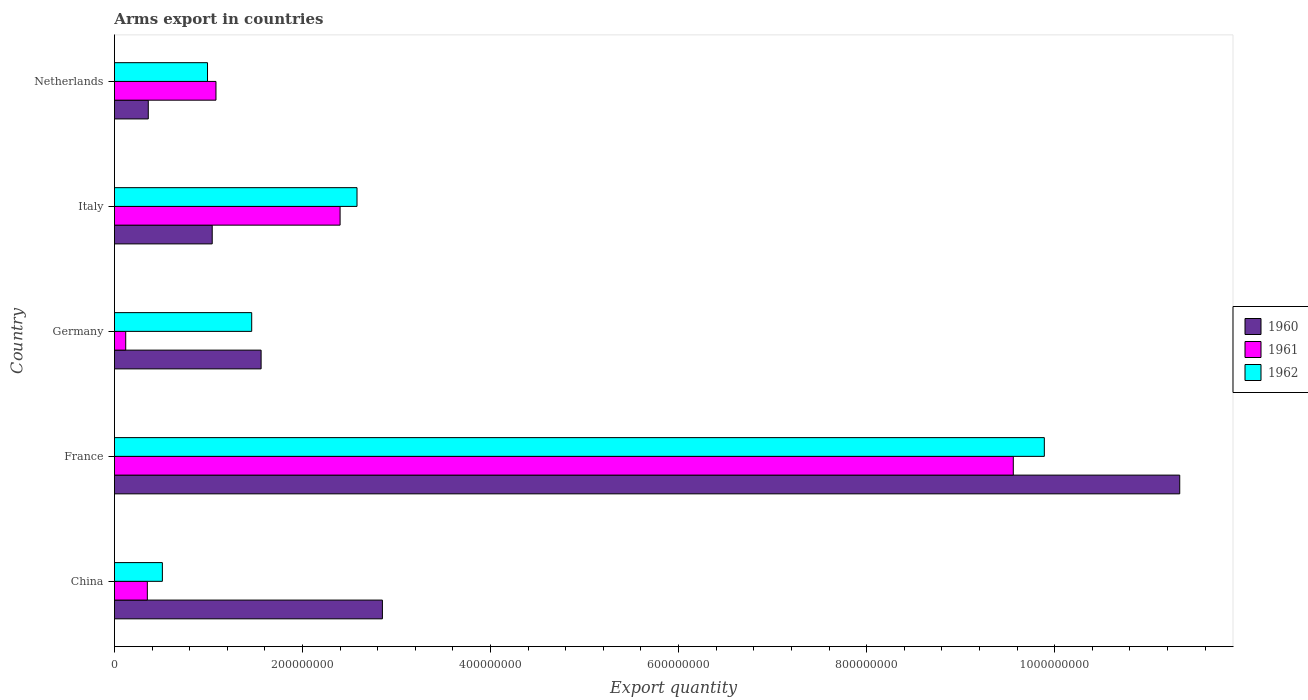How many groups of bars are there?
Give a very brief answer. 5. How many bars are there on the 1st tick from the top?
Provide a succinct answer. 3. What is the label of the 5th group of bars from the top?
Keep it short and to the point. China. What is the total arms export in 1961 in France?
Your answer should be very brief. 9.56e+08. Across all countries, what is the maximum total arms export in 1962?
Your response must be concise. 9.89e+08. In which country was the total arms export in 1961 maximum?
Give a very brief answer. France. What is the total total arms export in 1962 in the graph?
Provide a short and direct response. 1.54e+09. What is the difference between the total arms export in 1962 in China and that in Netherlands?
Your answer should be compact. -4.80e+07. What is the difference between the total arms export in 1962 in China and the total arms export in 1961 in France?
Your response must be concise. -9.05e+08. What is the average total arms export in 1960 per country?
Keep it short and to the point. 3.43e+08. What is the difference between the total arms export in 1960 and total arms export in 1962 in Germany?
Make the answer very short. 1.00e+07. What is the ratio of the total arms export in 1960 in China to that in Italy?
Provide a short and direct response. 2.74. Is the difference between the total arms export in 1960 in China and France greater than the difference between the total arms export in 1962 in China and France?
Offer a terse response. Yes. What is the difference between the highest and the second highest total arms export in 1961?
Give a very brief answer. 7.16e+08. What is the difference between the highest and the lowest total arms export in 1961?
Your answer should be compact. 9.44e+08. In how many countries, is the total arms export in 1961 greater than the average total arms export in 1961 taken over all countries?
Ensure brevity in your answer.  1. Is the sum of the total arms export in 1961 in China and Italy greater than the maximum total arms export in 1960 across all countries?
Your response must be concise. No. What does the 2nd bar from the top in Germany represents?
Offer a terse response. 1961. Are all the bars in the graph horizontal?
Provide a short and direct response. Yes. Does the graph contain any zero values?
Make the answer very short. No. Does the graph contain grids?
Your answer should be very brief. No. Where does the legend appear in the graph?
Keep it short and to the point. Center right. How many legend labels are there?
Your answer should be very brief. 3. What is the title of the graph?
Provide a short and direct response. Arms export in countries. Does "2007" appear as one of the legend labels in the graph?
Provide a short and direct response. No. What is the label or title of the X-axis?
Your response must be concise. Export quantity. What is the Export quantity of 1960 in China?
Ensure brevity in your answer.  2.85e+08. What is the Export quantity of 1961 in China?
Keep it short and to the point. 3.50e+07. What is the Export quantity in 1962 in China?
Ensure brevity in your answer.  5.10e+07. What is the Export quantity in 1960 in France?
Give a very brief answer. 1.13e+09. What is the Export quantity of 1961 in France?
Your answer should be very brief. 9.56e+08. What is the Export quantity in 1962 in France?
Offer a very short reply. 9.89e+08. What is the Export quantity of 1960 in Germany?
Provide a short and direct response. 1.56e+08. What is the Export quantity of 1962 in Germany?
Your response must be concise. 1.46e+08. What is the Export quantity in 1960 in Italy?
Provide a succinct answer. 1.04e+08. What is the Export quantity of 1961 in Italy?
Offer a terse response. 2.40e+08. What is the Export quantity in 1962 in Italy?
Provide a succinct answer. 2.58e+08. What is the Export quantity in 1960 in Netherlands?
Offer a terse response. 3.60e+07. What is the Export quantity in 1961 in Netherlands?
Your answer should be compact. 1.08e+08. What is the Export quantity in 1962 in Netherlands?
Your answer should be very brief. 9.90e+07. Across all countries, what is the maximum Export quantity in 1960?
Offer a very short reply. 1.13e+09. Across all countries, what is the maximum Export quantity in 1961?
Ensure brevity in your answer.  9.56e+08. Across all countries, what is the maximum Export quantity in 1962?
Give a very brief answer. 9.89e+08. Across all countries, what is the minimum Export quantity in 1960?
Ensure brevity in your answer.  3.60e+07. Across all countries, what is the minimum Export quantity in 1962?
Your answer should be compact. 5.10e+07. What is the total Export quantity of 1960 in the graph?
Provide a succinct answer. 1.71e+09. What is the total Export quantity of 1961 in the graph?
Offer a terse response. 1.35e+09. What is the total Export quantity in 1962 in the graph?
Give a very brief answer. 1.54e+09. What is the difference between the Export quantity of 1960 in China and that in France?
Your response must be concise. -8.48e+08. What is the difference between the Export quantity of 1961 in China and that in France?
Give a very brief answer. -9.21e+08. What is the difference between the Export quantity in 1962 in China and that in France?
Keep it short and to the point. -9.38e+08. What is the difference between the Export quantity in 1960 in China and that in Germany?
Keep it short and to the point. 1.29e+08. What is the difference between the Export quantity in 1961 in China and that in Germany?
Keep it short and to the point. 2.30e+07. What is the difference between the Export quantity in 1962 in China and that in Germany?
Provide a succinct answer. -9.50e+07. What is the difference between the Export quantity of 1960 in China and that in Italy?
Make the answer very short. 1.81e+08. What is the difference between the Export quantity in 1961 in China and that in Italy?
Give a very brief answer. -2.05e+08. What is the difference between the Export quantity of 1962 in China and that in Italy?
Provide a succinct answer. -2.07e+08. What is the difference between the Export quantity in 1960 in China and that in Netherlands?
Keep it short and to the point. 2.49e+08. What is the difference between the Export quantity in 1961 in China and that in Netherlands?
Your answer should be compact. -7.30e+07. What is the difference between the Export quantity in 1962 in China and that in Netherlands?
Ensure brevity in your answer.  -4.80e+07. What is the difference between the Export quantity of 1960 in France and that in Germany?
Give a very brief answer. 9.77e+08. What is the difference between the Export quantity in 1961 in France and that in Germany?
Provide a short and direct response. 9.44e+08. What is the difference between the Export quantity of 1962 in France and that in Germany?
Offer a terse response. 8.43e+08. What is the difference between the Export quantity of 1960 in France and that in Italy?
Provide a short and direct response. 1.03e+09. What is the difference between the Export quantity in 1961 in France and that in Italy?
Make the answer very short. 7.16e+08. What is the difference between the Export quantity in 1962 in France and that in Italy?
Provide a succinct answer. 7.31e+08. What is the difference between the Export quantity of 1960 in France and that in Netherlands?
Provide a short and direct response. 1.10e+09. What is the difference between the Export quantity in 1961 in France and that in Netherlands?
Your answer should be compact. 8.48e+08. What is the difference between the Export quantity in 1962 in France and that in Netherlands?
Your answer should be compact. 8.90e+08. What is the difference between the Export quantity of 1960 in Germany and that in Italy?
Your answer should be very brief. 5.20e+07. What is the difference between the Export quantity of 1961 in Germany and that in Italy?
Give a very brief answer. -2.28e+08. What is the difference between the Export quantity in 1962 in Germany and that in Italy?
Provide a succinct answer. -1.12e+08. What is the difference between the Export quantity of 1960 in Germany and that in Netherlands?
Offer a terse response. 1.20e+08. What is the difference between the Export quantity of 1961 in Germany and that in Netherlands?
Give a very brief answer. -9.60e+07. What is the difference between the Export quantity of 1962 in Germany and that in Netherlands?
Your answer should be compact. 4.70e+07. What is the difference between the Export quantity of 1960 in Italy and that in Netherlands?
Your response must be concise. 6.80e+07. What is the difference between the Export quantity of 1961 in Italy and that in Netherlands?
Keep it short and to the point. 1.32e+08. What is the difference between the Export quantity in 1962 in Italy and that in Netherlands?
Your response must be concise. 1.59e+08. What is the difference between the Export quantity in 1960 in China and the Export quantity in 1961 in France?
Your answer should be compact. -6.71e+08. What is the difference between the Export quantity in 1960 in China and the Export quantity in 1962 in France?
Provide a short and direct response. -7.04e+08. What is the difference between the Export quantity of 1961 in China and the Export quantity of 1962 in France?
Give a very brief answer. -9.54e+08. What is the difference between the Export quantity in 1960 in China and the Export quantity in 1961 in Germany?
Your response must be concise. 2.73e+08. What is the difference between the Export quantity of 1960 in China and the Export quantity of 1962 in Germany?
Ensure brevity in your answer.  1.39e+08. What is the difference between the Export quantity of 1961 in China and the Export quantity of 1962 in Germany?
Make the answer very short. -1.11e+08. What is the difference between the Export quantity of 1960 in China and the Export quantity of 1961 in Italy?
Provide a succinct answer. 4.50e+07. What is the difference between the Export quantity in 1960 in China and the Export quantity in 1962 in Italy?
Give a very brief answer. 2.70e+07. What is the difference between the Export quantity in 1961 in China and the Export quantity in 1962 in Italy?
Give a very brief answer. -2.23e+08. What is the difference between the Export quantity in 1960 in China and the Export quantity in 1961 in Netherlands?
Your response must be concise. 1.77e+08. What is the difference between the Export quantity of 1960 in China and the Export quantity of 1962 in Netherlands?
Ensure brevity in your answer.  1.86e+08. What is the difference between the Export quantity in 1961 in China and the Export quantity in 1962 in Netherlands?
Offer a very short reply. -6.40e+07. What is the difference between the Export quantity of 1960 in France and the Export quantity of 1961 in Germany?
Keep it short and to the point. 1.12e+09. What is the difference between the Export quantity in 1960 in France and the Export quantity in 1962 in Germany?
Make the answer very short. 9.87e+08. What is the difference between the Export quantity of 1961 in France and the Export quantity of 1962 in Germany?
Make the answer very short. 8.10e+08. What is the difference between the Export quantity of 1960 in France and the Export quantity of 1961 in Italy?
Your answer should be compact. 8.93e+08. What is the difference between the Export quantity of 1960 in France and the Export quantity of 1962 in Italy?
Keep it short and to the point. 8.75e+08. What is the difference between the Export quantity of 1961 in France and the Export quantity of 1962 in Italy?
Offer a very short reply. 6.98e+08. What is the difference between the Export quantity in 1960 in France and the Export quantity in 1961 in Netherlands?
Keep it short and to the point. 1.02e+09. What is the difference between the Export quantity in 1960 in France and the Export quantity in 1962 in Netherlands?
Ensure brevity in your answer.  1.03e+09. What is the difference between the Export quantity of 1961 in France and the Export quantity of 1962 in Netherlands?
Ensure brevity in your answer.  8.57e+08. What is the difference between the Export quantity of 1960 in Germany and the Export quantity of 1961 in Italy?
Offer a very short reply. -8.40e+07. What is the difference between the Export quantity of 1960 in Germany and the Export quantity of 1962 in Italy?
Offer a terse response. -1.02e+08. What is the difference between the Export quantity of 1961 in Germany and the Export quantity of 1962 in Italy?
Provide a short and direct response. -2.46e+08. What is the difference between the Export quantity in 1960 in Germany and the Export quantity in 1961 in Netherlands?
Provide a succinct answer. 4.80e+07. What is the difference between the Export quantity in 1960 in Germany and the Export quantity in 1962 in Netherlands?
Offer a very short reply. 5.70e+07. What is the difference between the Export quantity of 1961 in Germany and the Export quantity of 1962 in Netherlands?
Your answer should be very brief. -8.70e+07. What is the difference between the Export quantity in 1960 in Italy and the Export quantity in 1961 in Netherlands?
Ensure brevity in your answer.  -4.00e+06. What is the difference between the Export quantity in 1961 in Italy and the Export quantity in 1962 in Netherlands?
Offer a terse response. 1.41e+08. What is the average Export quantity in 1960 per country?
Your answer should be compact. 3.43e+08. What is the average Export quantity in 1961 per country?
Ensure brevity in your answer.  2.70e+08. What is the average Export quantity of 1962 per country?
Your response must be concise. 3.09e+08. What is the difference between the Export quantity of 1960 and Export quantity of 1961 in China?
Your answer should be compact. 2.50e+08. What is the difference between the Export quantity of 1960 and Export quantity of 1962 in China?
Make the answer very short. 2.34e+08. What is the difference between the Export quantity of 1961 and Export quantity of 1962 in China?
Your response must be concise. -1.60e+07. What is the difference between the Export quantity in 1960 and Export quantity in 1961 in France?
Your answer should be very brief. 1.77e+08. What is the difference between the Export quantity in 1960 and Export quantity in 1962 in France?
Offer a very short reply. 1.44e+08. What is the difference between the Export quantity of 1961 and Export quantity of 1962 in France?
Your answer should be very brief. -3.30e+07. What is the difference between the Export quantity of 1960 and Export quantity of 1961 in Germany?
Offer a very short reply. 1.44e+08. What is the difference between the Export quantity in 1960 and Export quantity in 1962 in Germany?
Ensure brevity in your answer.  1.00e+07. What is the difference between the Export quantity of 1961 and Export quantity of 1962 in Germany?
Give a very brief answer. -1.34e+08. What is the difference between the Export quantity of 1960 and Export quantity of 1961 in Italy?
Offer a very short reply. -1.36e+08. What is the difference between the Export quantity in 1960 and Export quantity in 1962 in Italy?
Make the answer very short. -1.54e+08. What is the difference between the Export quantity in 1961 and Export quantity in 1962 in Italy?
Provide a succinct answer. -1.80e+07. What is the difference between the Export quantity of 1960 and Export quantity of 1961 in Netherlands?
Make the answer very short. -7.20e+07. What is the difference between the Export quantity in 1960 and Export quantity in 1962 in Netherlands?
Your response must be concise. -6.30e+07. What is the difference between the Export quantity of 1961 and Export quantity of 1962 in Netherlands?
Offer a very short reply. 9.00e+06. What is the ratio of the Export quantity in 1960 in China to that in France?
Keep it short and to the point. 0.25. What is the ratio of the Export quantity in 1961 in China to that in France?
Your answer should be very brief. 0.04. What is the ratio of the Export quantity of 1962 in China to that in France?
Provide a short and direct response. 0.05. What is the ratio of the Export quantity of 1960 in China to that in Germany?
Offer a terse response. 1.83. What is the ratio of the Export quantity of 1961 in China to that in Germany?
Ensure brevity in your answer.  2.92. What is the ratio of the Export quantity in 1962 in China to that in Germany?
Offer a very short reply. 0.35. What is the ratio of the Export quantity of 1960 in China to that in Italy?
Provide a short and direct response. 2.74. What is the ratio of the Export quantity in 1961 in China to that in Italy?
Provide a succinct answer. 0.15. What is the ratio of the Export quantity in 1962 in China to that in Italy?
Your response must be concise. 0.2. What is the ratio of the Export quantity in 1960 in China to that in Netherlands?
Ensure brevity in your answer.  7.92. What is the ratio of the Export quantity in 1961 in China to that in Netherlands?
Give a very brief answer. 0.32. What is the ratio of the Export quantity of 1962 in China to that in Netherlands?
Your answer should be compact. 0.52. What is the ratio of the Export quantity in 1960 in France to that in Germany?
Offer a very short reply. 7.26. What is the ratio of the Export quantity in 1961 in France to that in Germany?
Ensure brevity in your answer.  79.67. What is the ratio of the Export quantity of 1962 in France to that in Germany?
Provide a short and direct response. 6.77. What is the ratio of the Export quantity of 1960 in France to that in Italy?
Give a very brief answer. 10.89. What is the ratio of the Export quantity of 1961 in France to that in Italy?
Keep it short and to the point. 3.98. What is the ratio of the Export quantity of 1962 in France to that in Italy?
Give a very brief answer. 3.83. What is the ratio of the Export quantity in 1960 in France to that in Netherlands?
Give a very brief answer. 31.47. What is the ratio of the Export quantity in 1961 in France to that in Netherlands?
Your answer should be compact. 8.85. What is the ratio of the Export quantity of 1962 in France to that in Netherlands?
Offer a terse response. 9.99. What is the ratio of the Export quantity in 1960 in Germany to that in Italy?
Your response must be concise. 1.5. What is the ratio of the Export quantity in 1961 in Germany to that in Italy?
Ensure brevity in your answer.  0.05. What is the ratio of the Export quantity in 1962 in Germany to that in Italy?
Give a very brief answer. 0.57. What is the ratio of the Export quantity of 1960 in Germany to that in Netherlands?
Offer a very short reply. 4.33. What is the ratio of the Export quantity in 1961 in Germany to that in Netherlands?
Give a very brief answer. 0.11. What is the ratio of the Export quantity in 1962 in Germany to that in Netherlands?
Offer a very short reply. 1.47. What is the ratio of the Export quantity in 1960 in Italy to that in Netherlands?
Provide a short and direct response. 2.89. What is the ratio of the Export quantity in 1961 in Italy to that in Netherlands?
Keep it short and to the point. 2.22. What is the ratio of the Export quantity in 1962 in Italy to that in Netherlands?
Make the answer very short. 2.61. What is the difference between the highest and the second highest Export quantity of 1960?
Give a very brief answer. 8.48e+08. What is the difference between the highest and the second highest Export quantity in 1961?
Make the answer very short. 7.16e+08. What is the difference between the highest and the second highest Export quantity in 1962?
Your response must be concise. 7.31e+08. What is the difference between the highest and the lowest Export quantity of 1960?
Your answer should be very brief. 1.10e+09. What is the difference between the highest and the lowest Export quantity in 1961?
Your answer should be very brief. 9.44e+08. What is the difference between the highest and the lowest Export quantity in 1962?
Offer a very short reply. 9.38e+08. 